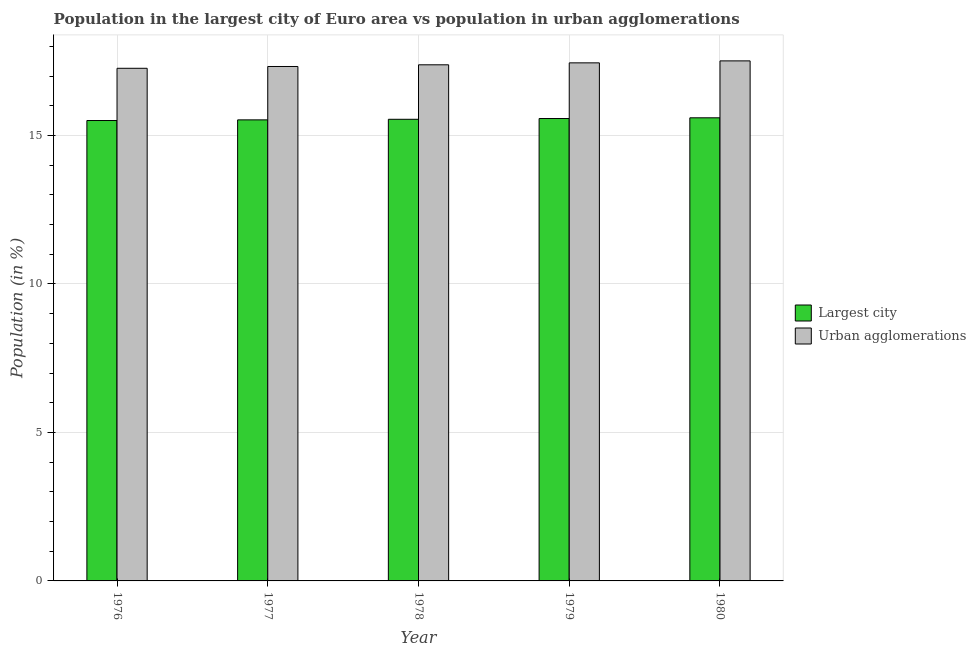How many groups of bars are there?
Keep it short and to the point. 5. Are the number of bars per tick equal to the number of legend labels?
Give a very brief answer. Yes. Are the number of bars on each tick of the X-axis equal?
Your response must be concise. Yes. How many bars are there on the 1st tick from the right?
Your answer should be very brief. 2. What is the population in urban agglomerations in 1979?
Offer a terse response. 17.44. Across all years, what is the maximum population in the largest city?
Your answer should be very brief. 15.59. Across all years, what is the minimum population in the largest city?
Offer a terse response. 15.5. In which year was the population in urban agglomerations maximum?
Provide a succinct answer. 1980. In which year was the population in the largest city minimum?
Offer a very short reply. 1976. What is the total population in the largest city in the graph?
Provide a succinct answer. 77.74. What is the difference between the population in the largest city in 1976 and that in 1979?
Offer a very short reply. -0.07. What is the difference between the population in the largest city in 1979 and the population in urban agglomerations in 1978?
Keep it short and to the point. 0.03. What is the average population in the largest city per year?
Give a very brief answer. 15.55. In the year 1976, what is the difference between the population in the largest city and population in urban agglomerations?
Your answer should be compact. 0. What is the ratio of the population in the largest city in 1979 to that in 1980?
Keep it short and to the point. 1. Is the population in urban agglomerations in 1976 less than that in 1979?
Your answer should be compact. Yes. What is the difference between the highest and the second highest population in the largest city?
Ensure brevity in your answer.  0.02. What is the difference between the highest and the lowest population in urban agglomerations?
Your answer should be very brief. 0.25. What does the 1st bar from the left in 1979 represents?
Offer a very short reply. Largest city. What does the 1st bar from the right in 1977 represents?
Your response must be concise. Urban agglomerations. Does the graph contain any zero values?
Provide a short and direct response. No. Does the graph contain grids?
Ensure brevity in your answer.  Yes. Where does the legend appear in the graph?
Ensure brevity in your answer.  Center right. How many legend labels are there?
Offer a very short reply. 2. How are the legend labels stacked?
Your answer should be compact. Vertical. What is the title of the graph?
Your answer should be very brief. Population in the largest city of Euro area vs population in urban agglomerations. What is the label or title of the X-axis?
Offer a very short reply. Year. What is the label or title of the Y-axis?
Your answer should be very brief. Population (in %). What is the Population (in %) of Largest city in 1976?
Your response must be concise. 15.5. What is the Population (in %) of Urban agglomerations in 1976?
Provide a succinct answer. 17.26. What is the Population (in %) of Largest city in 1977?
Make the answer very short. 15.53. What is the Population (in %) of Urban agglomerations in 1977?
Offer a very short reply. 17.32. What is the Population (in %) of Largest city in 1978?
Make the answer very short. 15.54. What is the Population (in %) of Urban agglomerations in 1978?
Offer a terse response. 17.38. What is the Population (in %) in Largest city in 1979?
Give a very brief answer. 15.57. What is the Population (in %) in Urban agglomerations in 1979?
Your answer should be compact. 17.44. What is the Population (in %) in Largest city in 1980?
Offer a very short reply. 15.59. What is the Population (in %) of Urban agglomerations in 1980?
Provide a short and direct response. 17.51. Across all years, what is the maximum Population (in %) in Largest city?
Keep it short and to the point. 15.59. Across all years, what is the maximum Population (in %) of Urban agglomerations?
Keep it short and to the point. 17.51. Across all years, what is the minimum Population (in %) in Largest city?
Provide a short and direct response. 15.5. Across all years, what is the minimum Population (in %) of Urban agglomerations?
Your answer should be very brief. 17.26. What is the total Population (in %) of Largest city in the graph?
Keep it short and to the point. 77.74. What is the total Population (in %) in Urban agglomerations in the graph?
Provide a succinct answer. 86.92. What is the difference between the Population (in %) of Largest city in 1976 and that in 1977?
Your answer should be very brief. -0.02. What is the difference between the Population (in %) of Urban agglomerations in 1976 and that in 1977?
Provide a short and direct response. -0.06. What is the difference between the Population (in %) in Largest city in 1976 and that in 1978?
Offer a very short reply. -0.04. What is the difference between the Population (in %) of Urban agglomerations in 1976 and that in 1978?
Offer a very short reply. -0.12. What is the difference between the Population (in %) in Largest city in 1976 and that in 1979?
Your answer should be compact. -0.07. What is the difference between the Population (in %) in Urban agglomerations in 1976 and that in 1979?
Your response must be concise. -0.18. What is the difference between the Population (in %) in Largest city in 1976 and that in 1980?
Ensure brevity in your answer.  -0.09. What is the difference between the Population (in %) in Urban agglomerations in 1976 and that in 1980?
Make the answer very short. -0.25. What is the difference between the Population (in %) in Largest city in 1977 and that in 1978?
Make the answer very short. -0.02. What is the difference between the Population (in %) in Urban agglomerations in 1977 and that in 1978?
Your answer should be compact. -0.06. What is the difference between the Population (in %) of Largest city in 1977 and that in 1979?
Provide a short and direct response. -0.05. What is the difference between the Population (in %) of Urban agglomerations in 1977 and that in 1979?
Provide a succinct answer. -0.12. What is the difference between the Population (in %) of Largest city in 1977 and that in 1980?
Keep it short and to the point. -0.07. What is the difference between the Population (in %) in Urban agglomerations in 1977 and that in 1980?
Your answer should be very brief. -0.19. What is the difference between the Population (in %) in Largest city in 1978 and that in 1979?
Your answer should be compact. -0.03. What is the difference between the Population (in %) of Urban agglomerations in 1978 and that in 1979?
Offer a very short reply. -0.07. What is the difference between the Population (in %) of Largest city in 1978 and that in 1980?
Your answer should be very brief. -0.05. What is the difference between the Population (in %) in Urban agglomerations in 1978 and that in 1980?
Your answer should be very brief. -0.13. What is the difference between the Population (in %) in Largest city in 1979 and that in 1980?
Your answer should be very brief. -0.02. What is the difference between the Population (in %) of Urban agglomerations in 1979 and that in 1980?
Your answer should be compact. -0.07. What is the difference between the Population (in %) in Largest city in 1976 and the Population (in %) in Urban agglomerations in 1977?
Provide a succinct answer. -1.82. What is the difference between the Population (in %) of Largest city in 1976 and the Population (in %) of Urban agglomerations in 1978?
Your response must be concise. -1.88. What is the difference between the Population (in %) of Largest city in 1976 and the Population (in %) of Urban agglomerations in 1979?
Give a very brief answer. -1.94. What is the difference between the Population (in %) in Largest city in 1976 and the Population (in %) in Urban agglomerations in 1980?
Offer a terse response. -2.01. What is the difference between the Population (in %) in Largest city in 1977 and the Population (in %) in Urban agglomerations in 1978?
Offer a terse response. -1.85. What is the difference between the Population (in %) in Largest city in 1977 and the Population (in %) in Urban agglomerations in 1979?
Give a very brief answer. -1.92. What is the difference between the Population (in %) of Largest city in 1977 and the Population (in %) of Urban agglomerations in 1980?
Provide a succinct answer. -1.99. What is the difference between the Population (in %) of Largest city in 1978 and the Population (in %) of Urban agglomerations in 1979?
Ensure brevity in your answer.  -1.9. What is the difference between the Population (in %) of Largest city in 1978 and the Population (in %) of Urban agglomerations in 1980?
Provide a short and direct response. -1.97. What is the difference between the Population (in %) of Largest city in 1979 and the Population (in %) of Urban agglomerations in 1980?
Your answer should be compact. -1.94. What is the average Population (in %) in Largest city per year?
Your response must be concise. 15.55. What is the average Population (in %) of Urban agglomerations per year?
Keep it short and to the point. 17.38. In the year 1976, what is the difference between the Population (in %) in Largest city and Population (in %) in Urban agglomerations?
Provide a succinct answer. -1.76. In the year 1977, what is the difference between the Population (in %) in Largest city and Population (in %) in Urban agglomerations?
Make the answer very short. -1.8. In the year 1978, what is the difference between the Population (in %) in Largest city and Population (in %) in Urban agglomerations?
Give a very brief answer. -1.83. In the year 1979, what is the difference between the Population (in %) of Largest city and Population (in %) of Urban agglomerations?
Your response must be concise. -1.87. In the year 1980, what is the difference between the Population (in %) of Largest city and Population (in %) of Urban agglomerations?
Provide a succinct answer. -1.92. What is the ratio of the Population (in %) of Largest city in 1976 to that in 1977?
Offer a terse response. 1. What is the ratio of the Population (in %) in Largest city in 1976 to that in 1978?
Offer a very short reply. 1. What is the ratio of the Population (in %) in Urban agglomerations in 1976 to that in 1980?
Offer a very short reply. 0.99. What is the ratio of the Population (in %) in Largest city in 1977 to that in 1978?
Provide a short and direct response. 1. What is the ratio of the Population (in %) in Largest city in 1977 to that in 1980?
Offer a very short reply. 1. What is the ratio of the Population (in %) in Largest city in 1978 to that in 1979?
Give a very brief answer. 1. What is the ratio of the Population (in %) in Urban agglomerations in 1978 to that in 1979?
Your answer should be compact. 1. What is the ratio of the Population (in %) of Urban agglomerations in 1978 to that in 1980?
Keep it short and to the point. 0.99. What is the ratio of the Population (in %) of Largest city in 1979 to that in 1980?
Your response must be concise. 1. What is the difference between the highest and the second highest Population (in %) in Largest city?
Keep it short and to the point. 0.02. What is the difference between the highest and the second highest Population (in %) of Urban agglomerations?
Provide a succinct answer. 0.07. What is the difference between the highest and the lowest Population (in %) of Largest city?
Your answer should be compact. 0.09. What is the difference between the highest and the lowest Population (in %) in Urban agglomerations?
Provide a succinct answer. 0.25. 